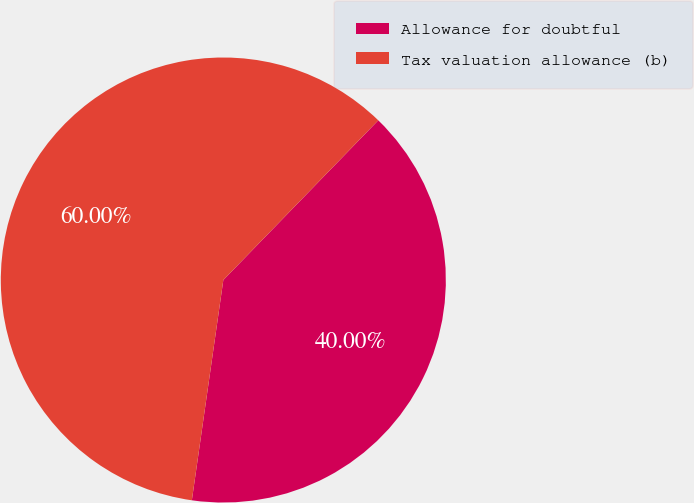Convert chart to OTSL. <chart><loc_0><loc_0><loc_500><loc_500><pie_chart><fcel>Allowance for doubtful<fcel>Tax valuation allowance (b)<nl><fcel>40.0%<fcel>60.0%<nl></chart> 